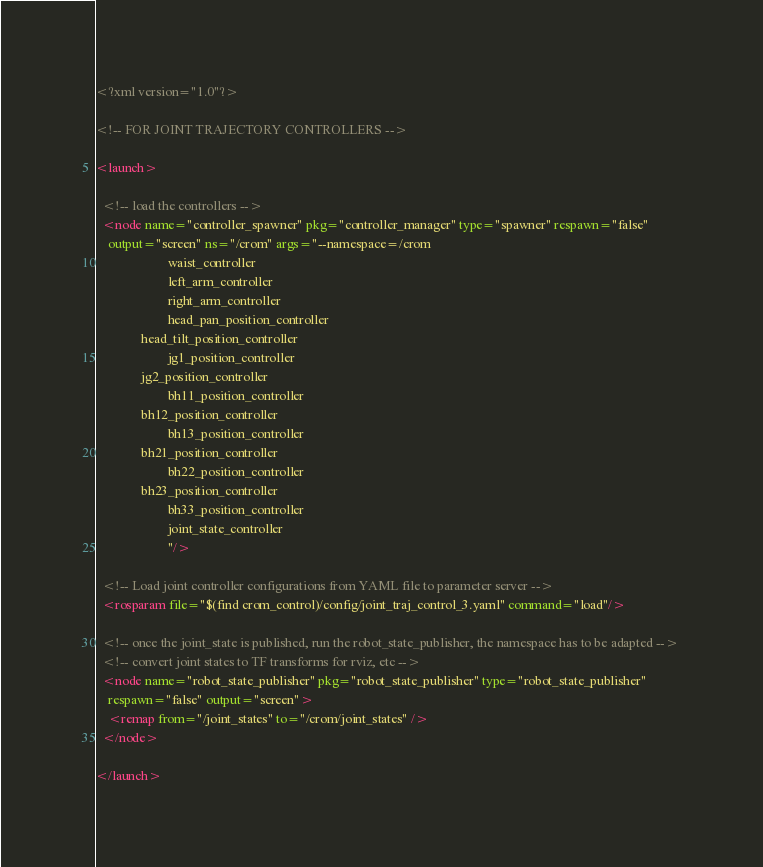Convert code to text. <code><loc_0><loc_0><loc_500><loc_500><_XML_><?xml version="1.0"?>

<!-- FOR JOINT TRAJECTORY CONTROLLERS -->

<launch>

  <!-- load the controllers -->
  <node name="controller_spawner" pkg="controller_manager" type="spawner" respawn="false"
    output="screen" ns="/crom" args="--namespace=/crom
                      waist_controller               
                      left_arm_controller                
                      right_arm_controller                              
                      head_pan_position_controller   
  		      head_tilt_position_controller                                
                      jg1_position_controller   
  		      jg2_position_controller                                                   
                      bh11_position_controller
		      bh12_position_controller
                      bh13_position_controller
		      bh21_position_controller 
                      bh22_position_controller
		      bh23_position_controller 
                      bh33_position_controller                          
                      joint_state_controller 
                      "/>

  <!-- Load joint controller configurations from YAML file to parameter server -->
  <rosparam file="$(find crom_control)/config/joint_traj_control_3.yaml" command="load"/>

  <!-- once the joint_state is published, run the robot_state_publisher, the namespace has to be adapted --> 
  <!-- convert joint states to TF transforms for rviz, etc -->
  <node name="robot_state_publisher" pkg="robot_state_publisher" type="robot_state_publisher"
    respawn="false" output="screen">
    <remap from="/joint_states" to="/crom/joint_states" />
  </node>

</launch>

</code> 